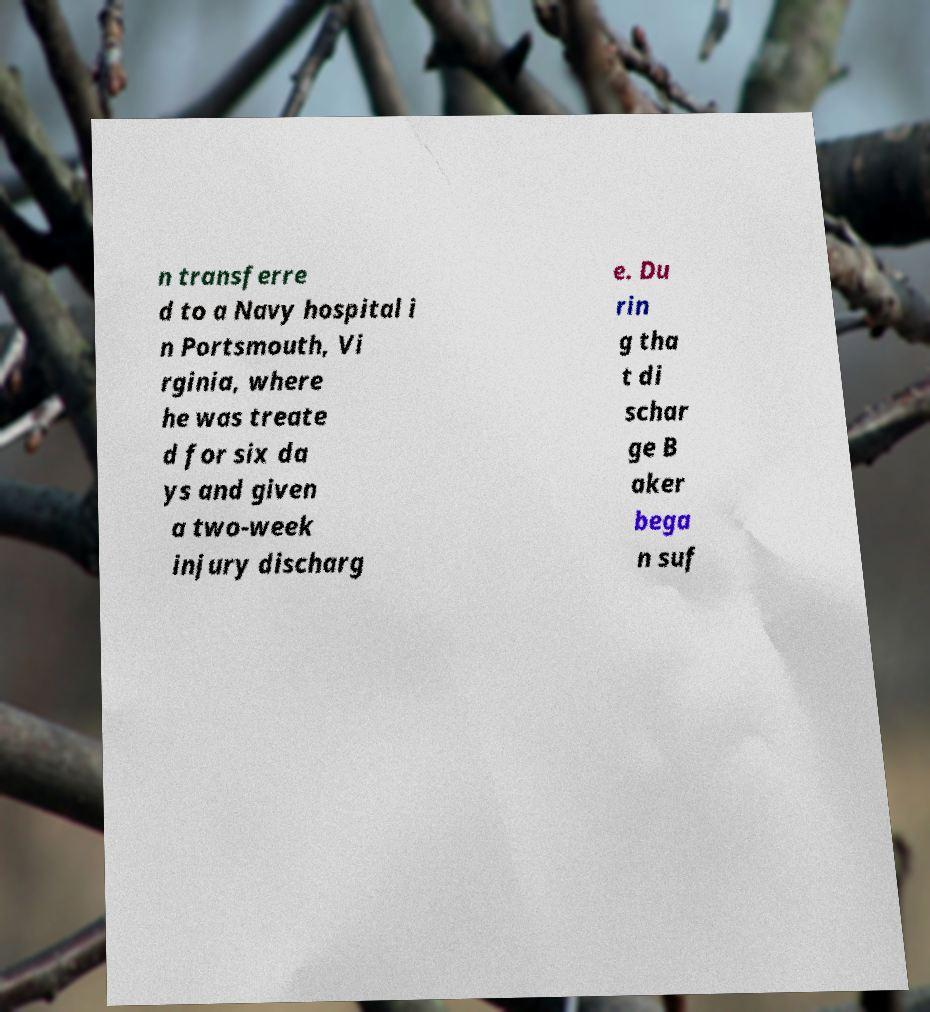Could you extract and type out the text from this image? n transferre d to a Navy hospital i n Portsmouth, Vi rginia, where he was treate d for six da ys and given a two-week injury discharg e. Du rin g tha t di schar ge B aker bega n suf 